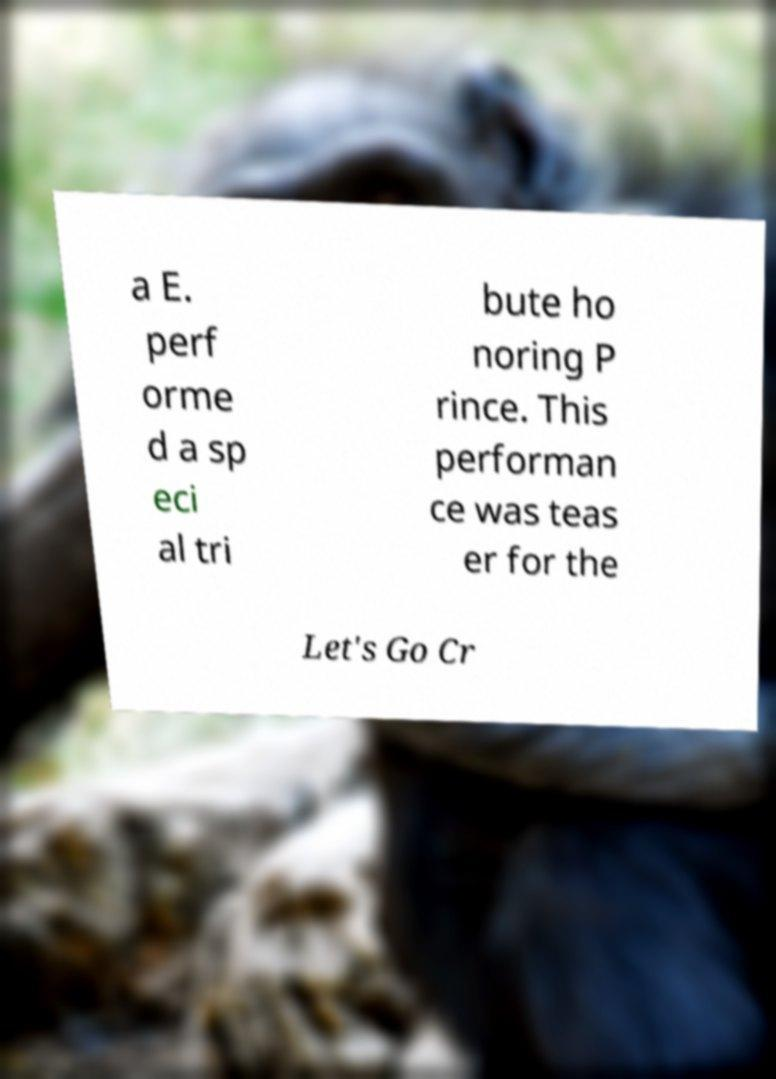There's text embedded in this image that I need extracted. Can you transcribe it verbatim? a E. perf orme d a sp eci al tri bute ho noring P rince. This performan ce was teas er for the Let's Go Cr 